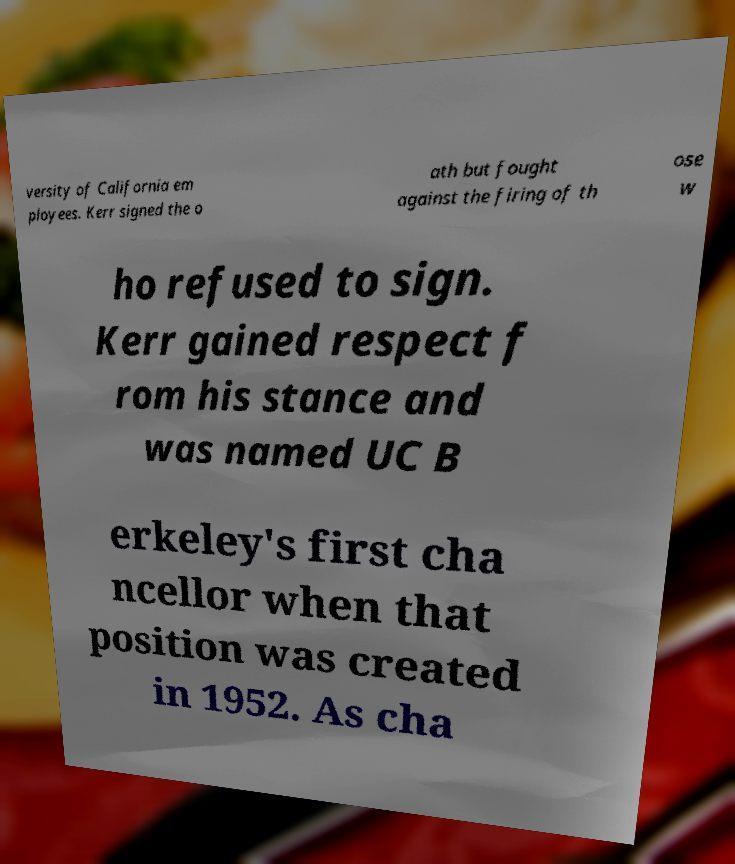I need the written content from this picture converted into text. Can you do that? versity of California em ployees. Kerr signed the o ath but fought against the firing of th ose w ho refused to sign. Kerr gained respect f rom his stance and was named UC B erkeley's first cha ncellor when that position was created in 1952. As cha 